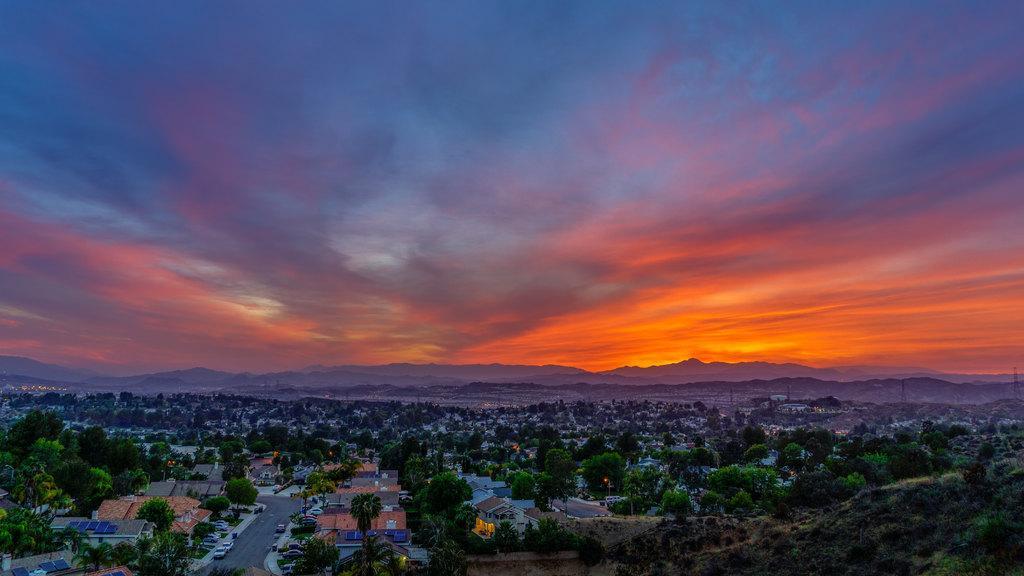In one or two sentences, can you explain what this image depicts? In this image we can see a sky. There are many trees in the image. There are many houses and building in the image. There is a road in the image. There are many vehicles in the image. There are many hills in the image. 